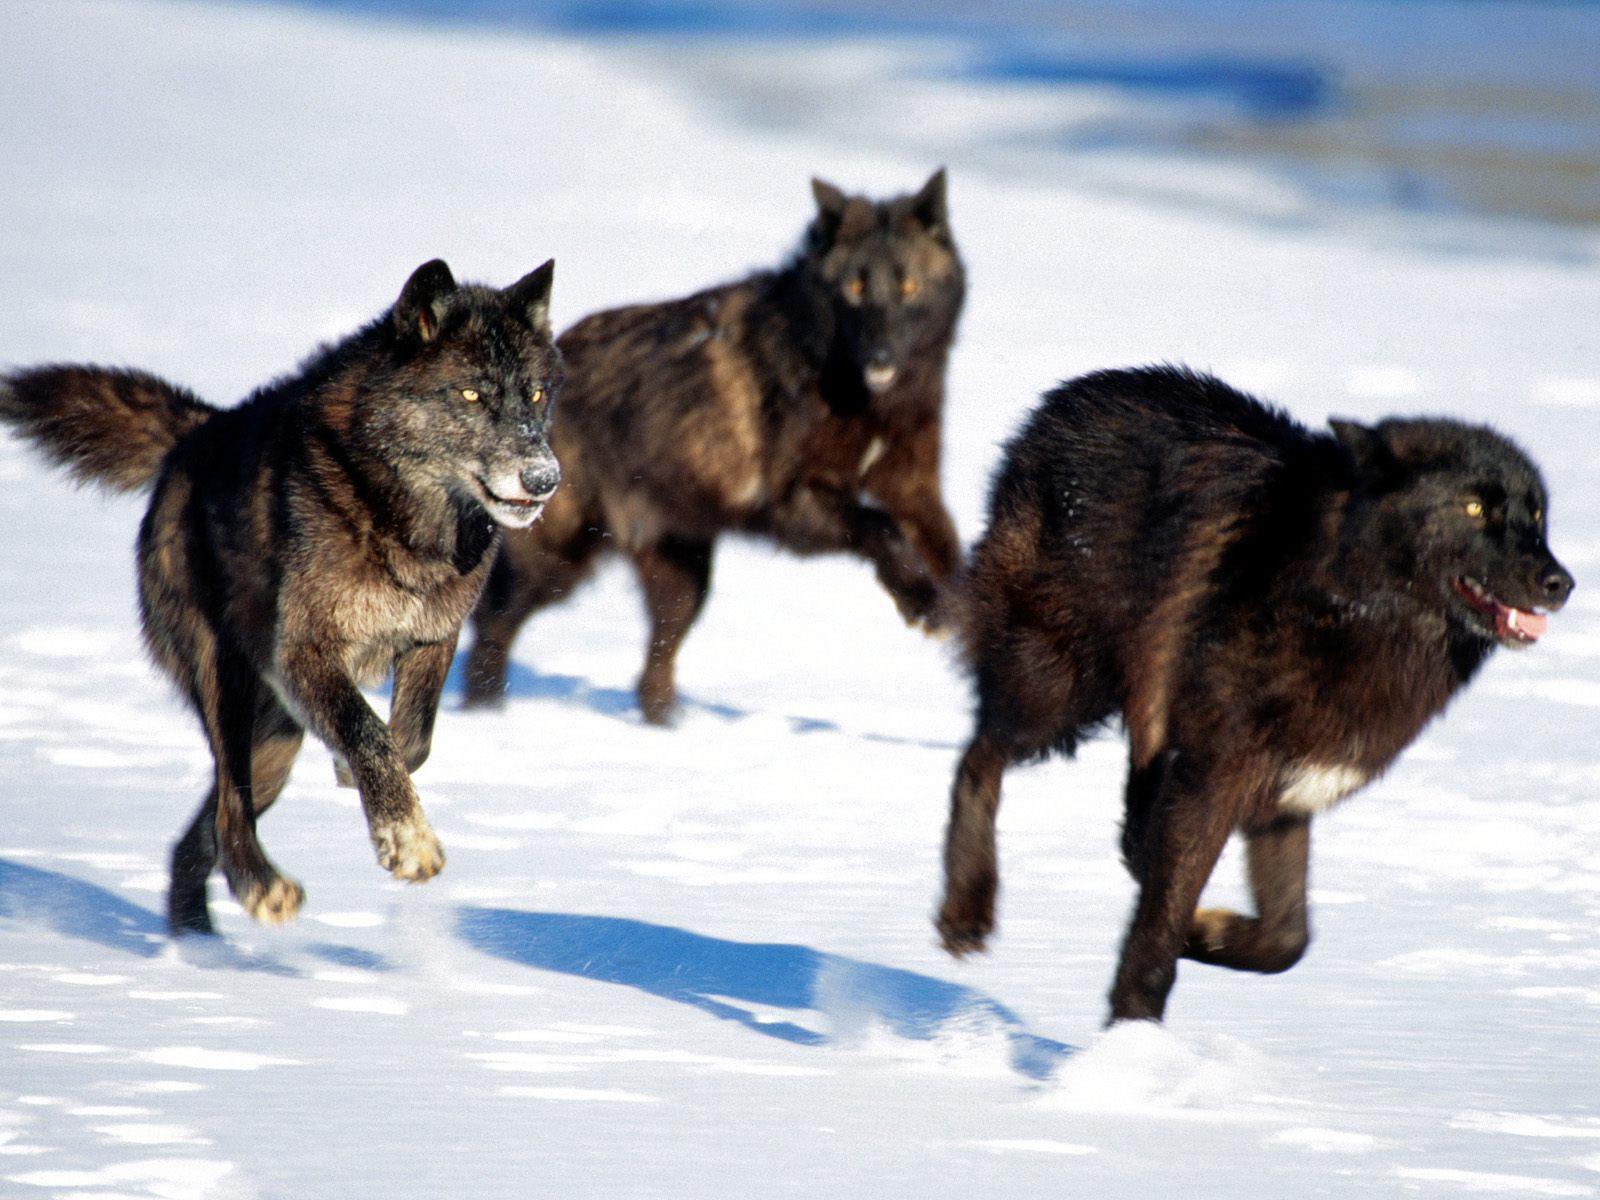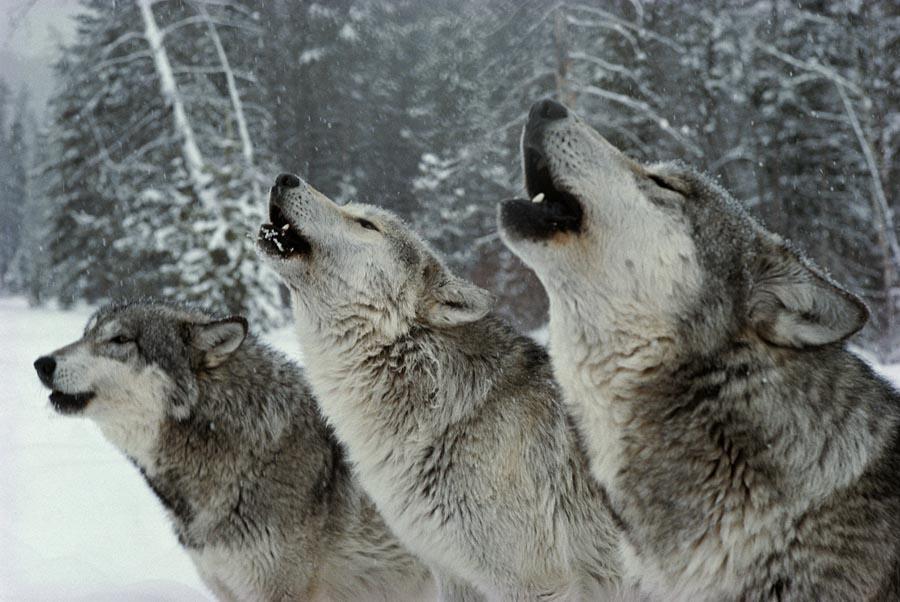The first image is the image on the left, the second image is the image on the right. Examine the images to the left and right. Is the description "wolves are feasting on a carcass" accurate? Answer yes or no. No. 